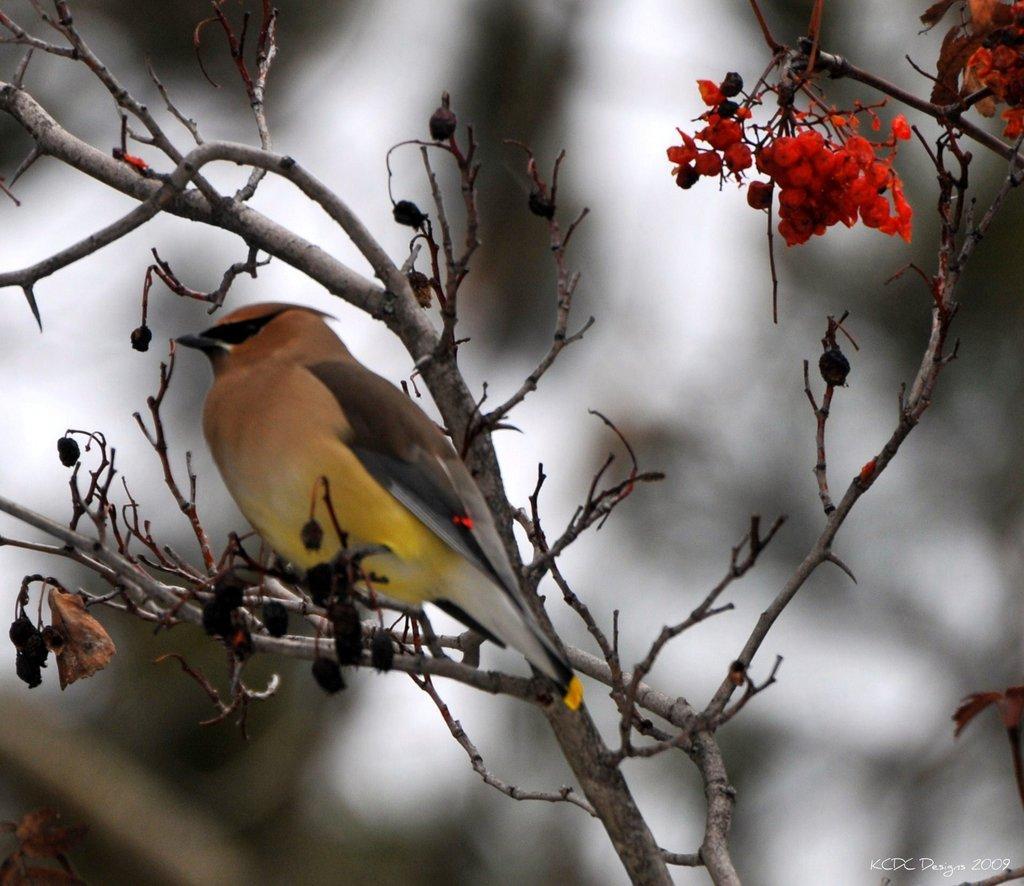Could you give a brief overview of what you see in this image? On the left side, there is a bird on a branch of a tree which is having fruits. And the background is blurred. 